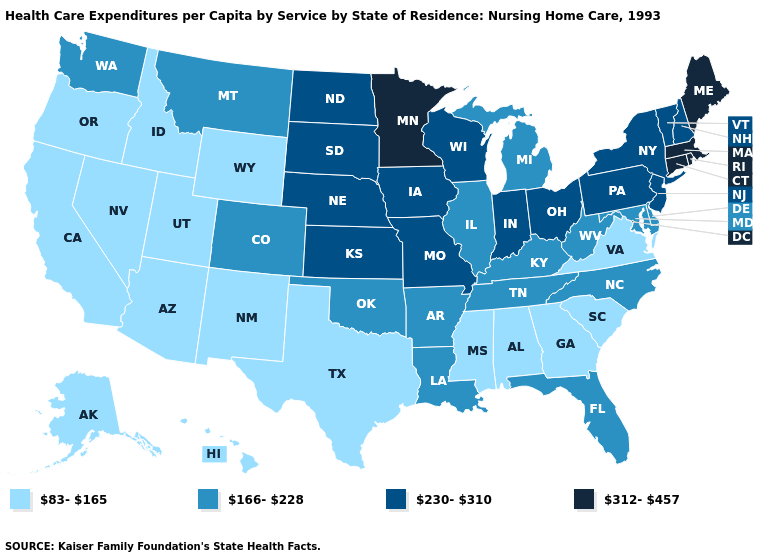What is the value of Montana?
Keep it brief. 166-228. Does Arkansas have a lower value than Connecticut?
Quick response, please. Yes. What is the value of Mississippi?
Short answer required. 83-165. Name the states that have a value in the range 166-228?
Short answer required. Arkansas, Colorado, Delaware, Florida, Illinois, Kentucky, Louisiana, Maryland, Michigan, Montana, North Carolina, Oklahoma, Tennessee, Washington, West Virginia. Name the states that have a value in the range 83-165?
Keep it brief. Alabama, Alaska, Arizona, California, Georgia, Hawaii, Idaho, Mississippi, Nevada, New Mexico, Oregon, South Carolina, Texas, Utah, Virginia, Wyoming. What is the value of Illinois?
Answer briefly. 166-228. Does the map have missing data?
Write a very short answer. No. Name the states that have a value in the range 166-228?
Answer briefly. Arkansas, Colorado, Delaware, Florida, Illinois, Kentucky, Louisiana, Maryland, Michigan, Montana, North Carolina, Oklahoma, Tennessee, Washington, West Virginia. Name the states that have a value in the range 166-228?
Quick response, please. Arkansas, Colorado, Delaware, Florida, Illinois, Kentucky, Louisiana, Maryland, Michigan, Montana, North Carolina, Oklahoma, Tennessee, Washington, West Virginia. Name the states that have a value in the range 166-228?
Be succinct. Arkansas, Colorado, Delaware, Florida, Illinois, Kentucky, Louisiana, Maryland, Michigan, Montana, North Carolina, Oklahoma, Tennessee, Washington, West Virginia. What is the value of North Carolina?
Be succinct. 166-228. Among the states that border Wyoming , which have the highest value?
Short answer required. Nebraska, South Dakota. What is the highest value in states that border Florida?
Answer briefly. 83-165. Name the states that have a value in the range 312-457?
Quick response, please. Connecticut, Maine, Massachusetts, Minnesota, Rhode Island. What is the highest value in the West ?
Give a very brief answer. 166-228. 